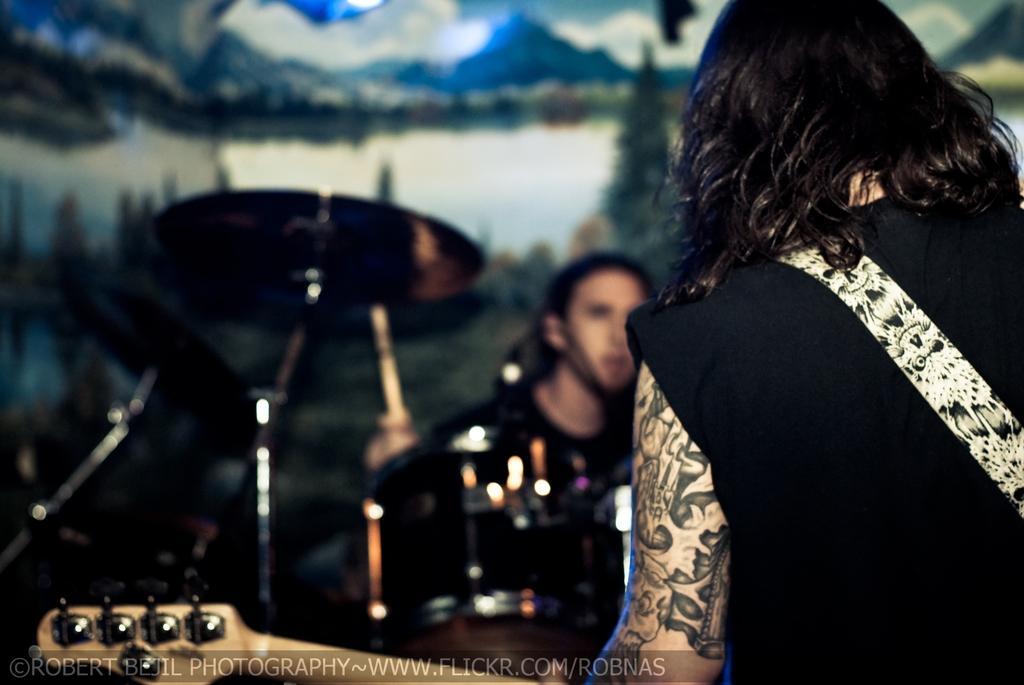Please provide a concise description of this image. in the picture we can see a person holding guitar ,here we can also see some musical instruments. 